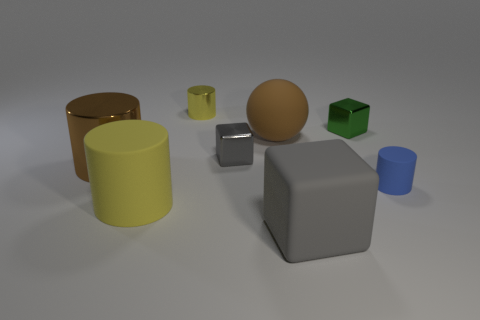Subtract all brown metal cylinders. How many cylinders are left? 3 Subtract all green cubes. How many cubes are left? 2 Add 1 small blue spheres. How many objects exist? 9 Subtract all yellow cylinders. How many gray cubes are left? 2 Subtract all spheres. How many objects are left? 7 Add 7 yellow things. How many yellow things are left? 9 Add 7 tiny brown cubes. How many tiny brown cubes exist? 7 Subtract 0 cyan cubes. How many objects are left? 8 Subtract 2 cubes. How many cubes are left? 1 Subtract all brown cubes. Subtract all cyan cylinders. How many cubes are left? 3 